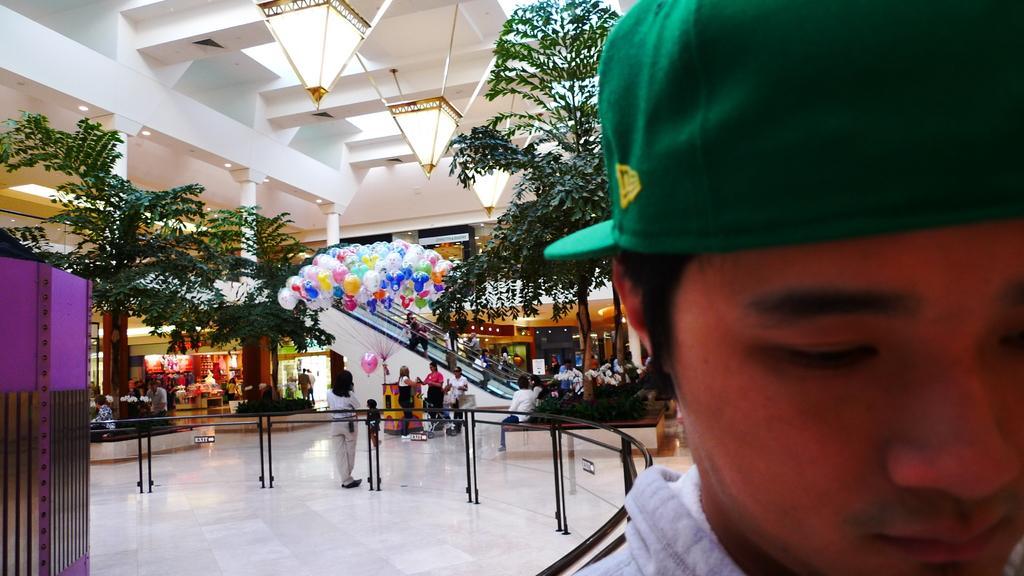In one or two sentences, can you explain what this image depicts? In the foreground we can see a person wearing dress and a green cap. In the background, we can see metal barricade, a group of people standing on floor, balloons, a group of trees and the staircase and some lights. 